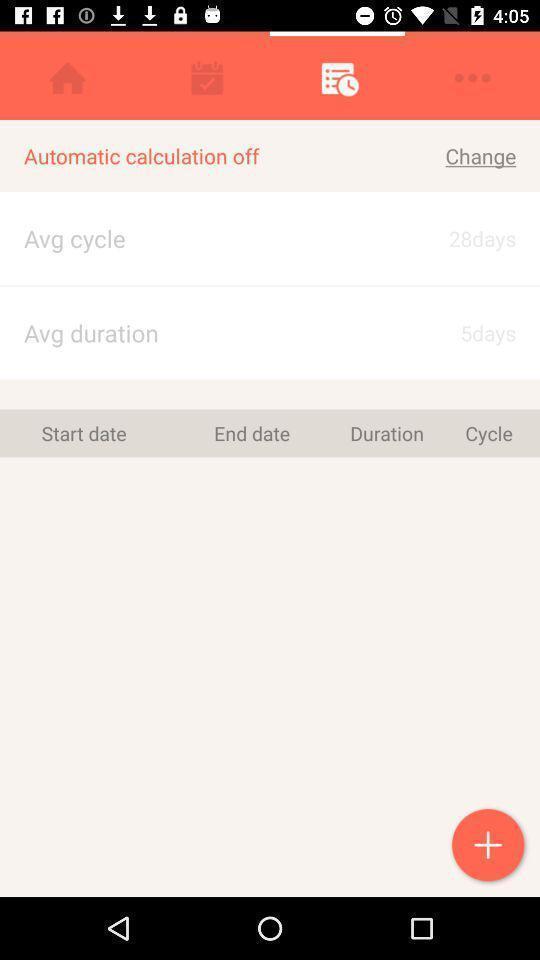Provide a description of this screenshot. Social app for calculating your personal things. 